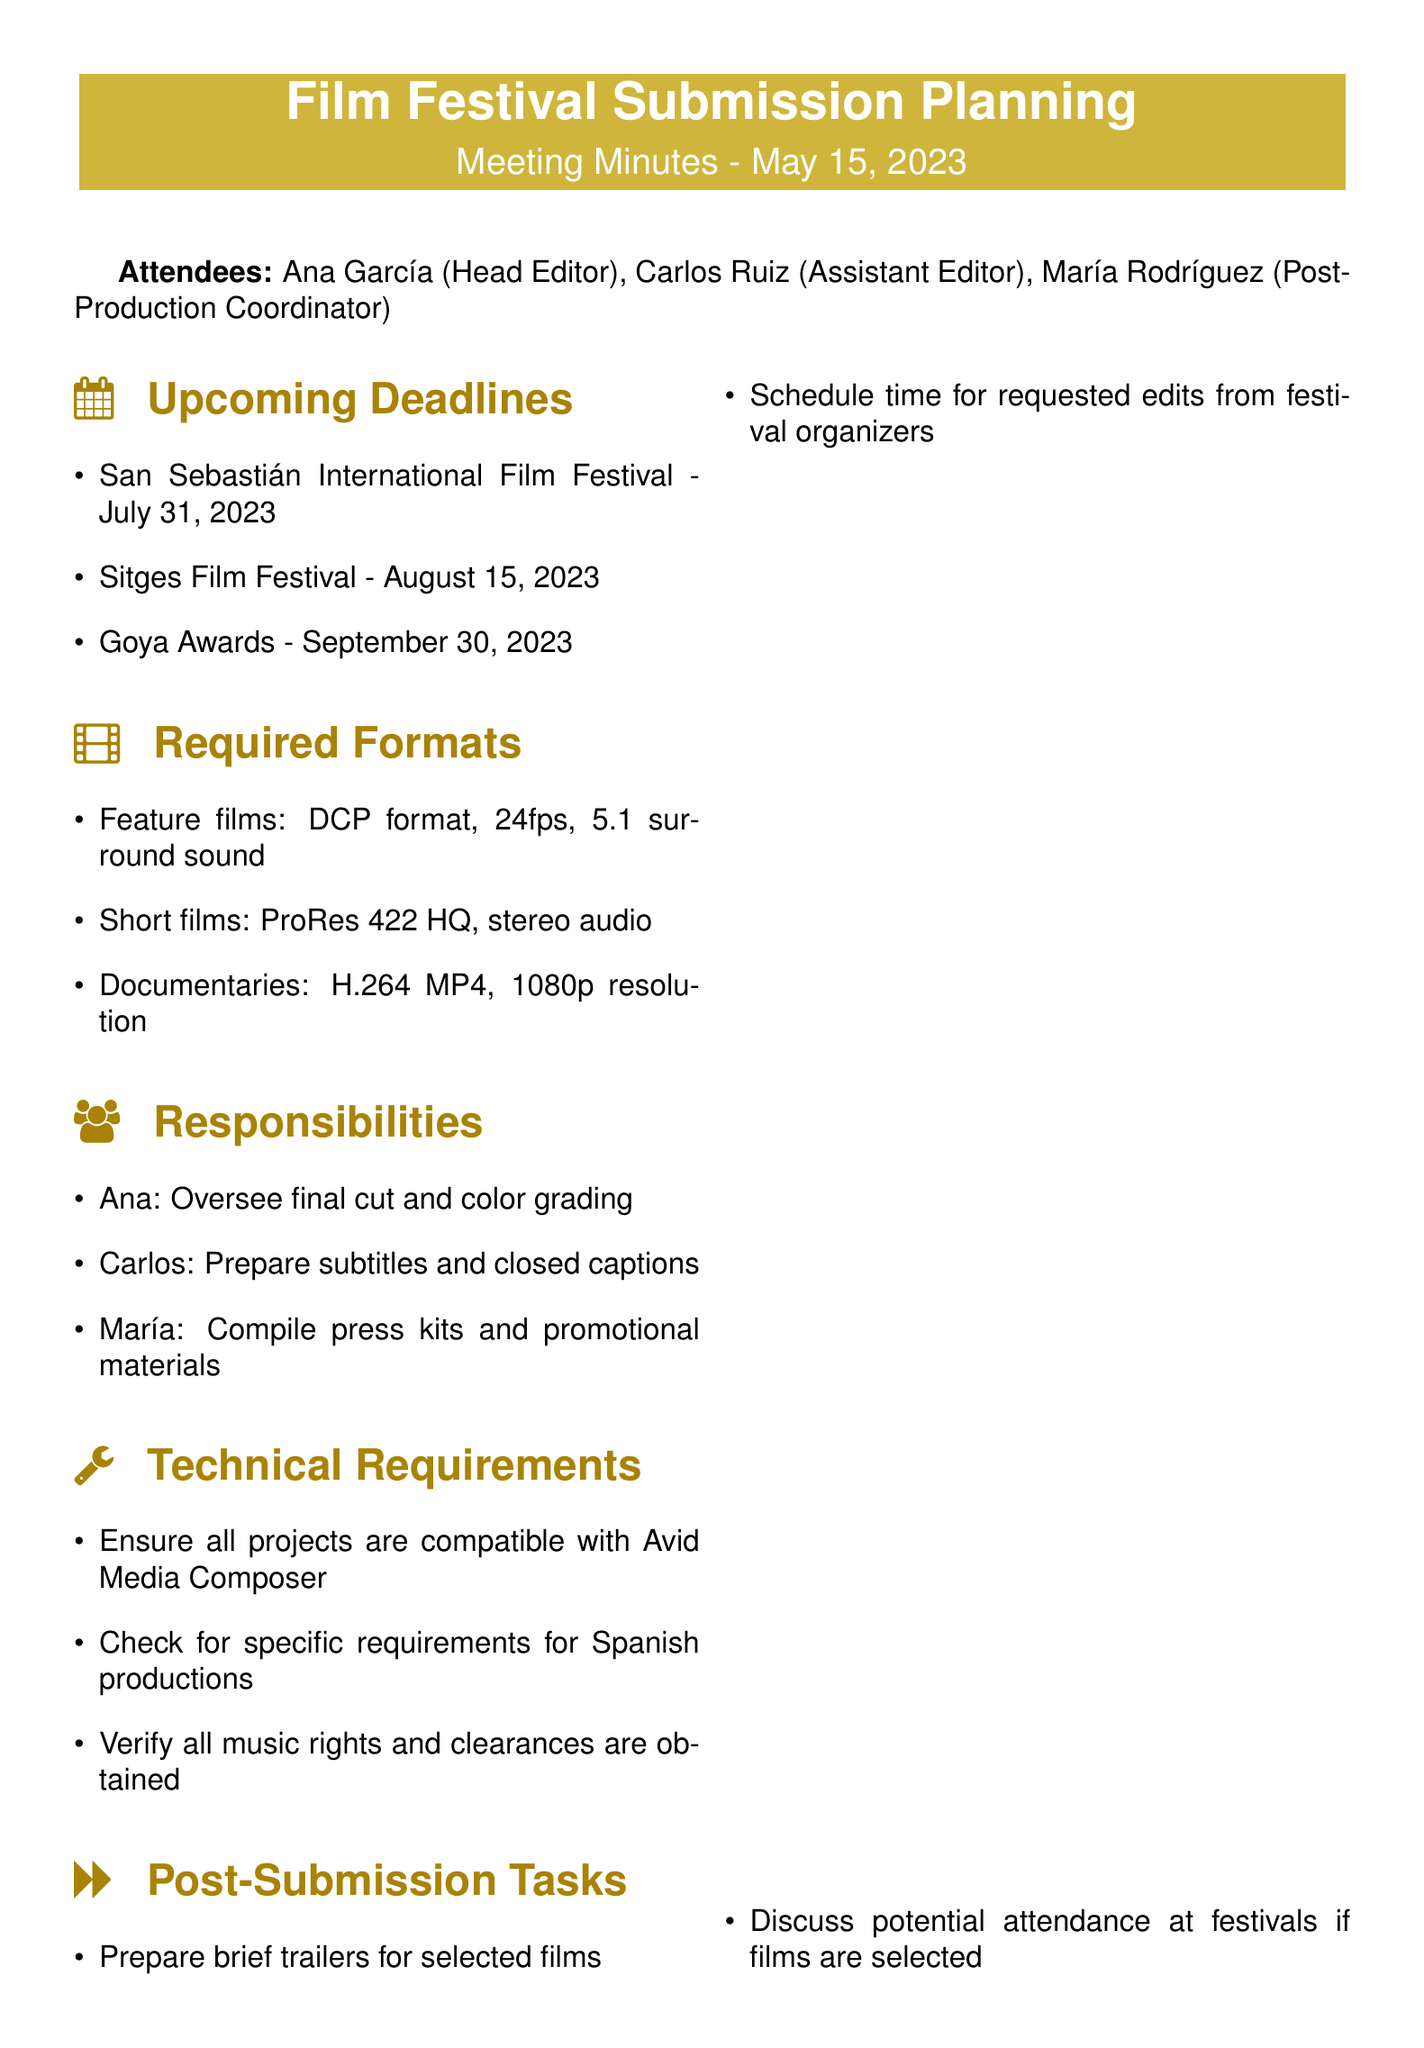What is the meeting title? The title of the meeting is indicated at the top of the document.
Answer: Film Festival Submission Planning When is the deadline for the San Sebastián International Film Festival? The specific date is listed under the upcoming deadlines section.
Answer: July 31, 2023 What format is required for feature films? The required format is detailed under the required formats section.
Answer: DCP format, 24fps, 5.1 surround sound Who is responsible for preparing subtitles? The responsibilities section states who is assigned to various tasks.
Answer: Carlos What is one task planned for post-submission? The document lists tasks related to post-submission in the relevant section.
Answer: Prepare brief trailers for selected films How many attendees were present at the meeting? The attendees are listed at the beginning of the document.
Answer: Three What action item is assigned to María? The action items section contains specific assignments for different attendees.
Answer: Contact festival organizers for any specific Spanish language requirements Is music rights verification mentioned in the document? The technical requirements section includes this as part of the necessary checks.
Answer: Yes What time frame covers the festival submission deadlines? The deadlines are provided in the upcoming deadlines section.
Answer: July to September 2023 